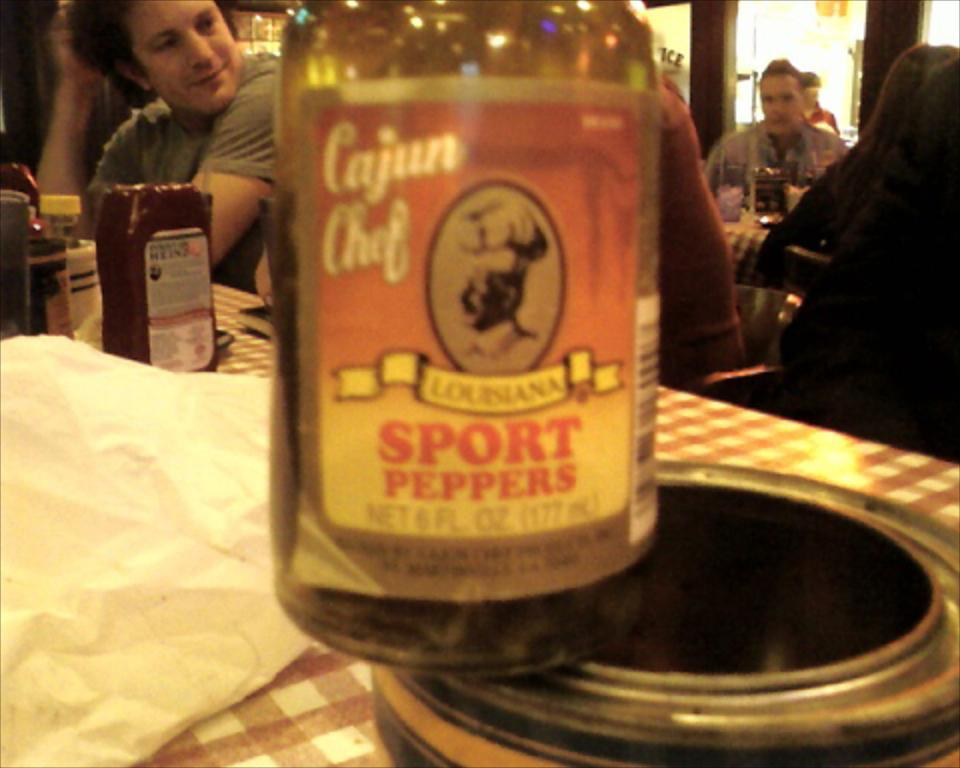What is the main subject of the image? The main subject of the image is a person. What is the person doing or interacting with in the image? The provided facts do not specify what the person is doing or interacting with. Can you describe the setting or environment in the image? The only information given is that there is an object or objects on a table. How many objects are on the table? The provided facts do not specify the number of objects on the table. What type of needle is the person using to make an observation in the image? There is no needle or observation present in the image. 